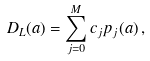Convert formula to latex. <formula><loc_0><loc_0><loc_500><loc_500>D _ { L } ( a ) = \sum _ { j = 0 } ^ { M } c _ { j } p _ { j } ( a ) \, ,</formula> 